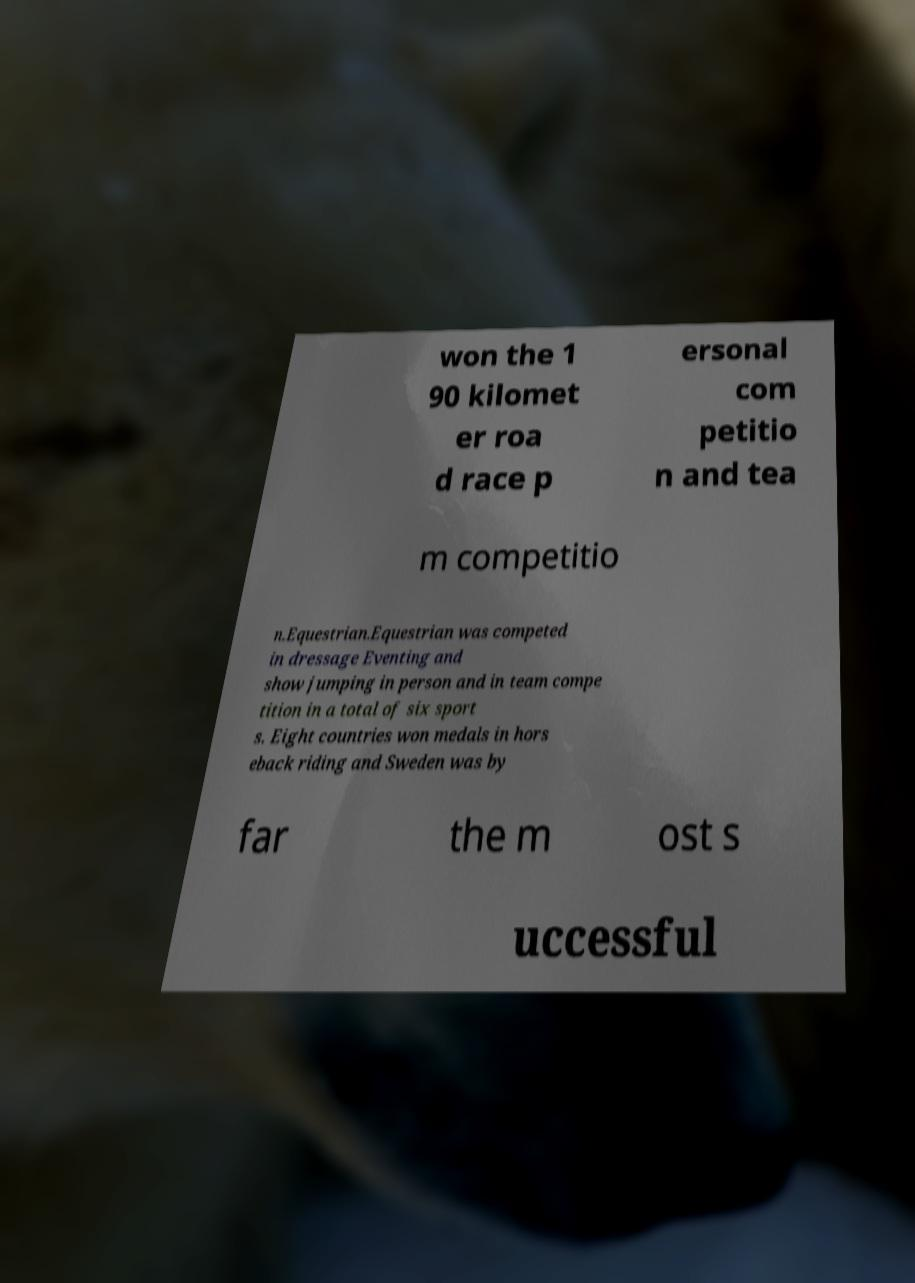Please identify and transcribe the text found in this image. won the 1 90 kilomet er roa d race p ersonal com petitio n and tea m competitio n.Equestrian.Equestrian was competed in dressage Eventing and show jumping in person and in team compe tition in a total of six sport s. Eight countries won medals in hors eback riding and Sweden was by far the m ost s uccessful 